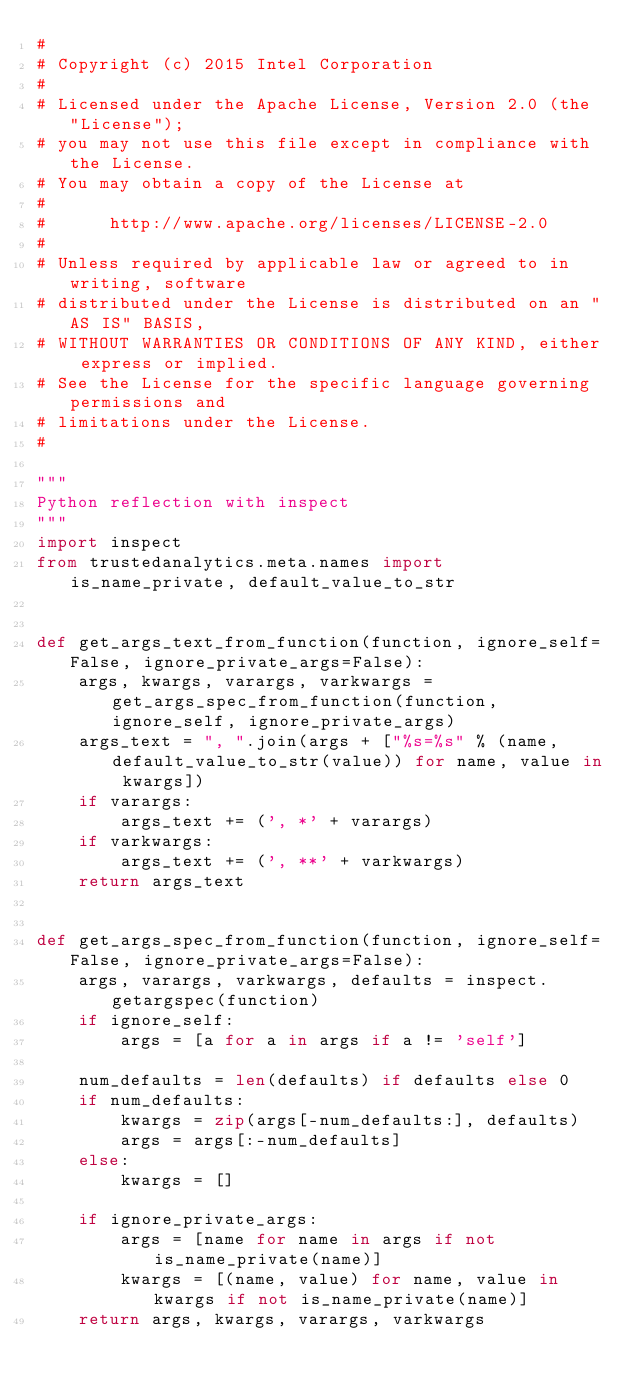Convert code to text. <code><loc_0><loc_0><loc_500><loc_500><_Python_>#
# Copyright (c) 2015 Intel Corporation 
#
# Licensed under the Apache License, Version 2.0 (the "License");
# you may not use this file except in compliance with the License.
# You may obtain a copy of the License at
#
#      http://www.apache.org/licenses/LICENSE-2.0
#
# Unless required by applicable law or agreed to in writing, software
# distributed under the License is distributed on an "AS IS" BASIS,
# WITHOUT WARRANTIES OR CONDITIONS OF ANY KIND, either express or implied.
# See the License for the specific language governing permissions and
# limitations under the License.
#

"""
Python reflection with inspect
"""
import inspect
from trustedanalytics.meta.names import is_name_private, default_value_to_str


def get_args_text_from_function(function, ignore_self=False, ignore_private_args=False):
    args, kwargs, varargs, varkwargs = get_args_spec_from_function(function, ignore_self, ignore_private_args)
    args_text = ", ".join(args + ["%s=%s" % (name, default_value_to_str(value)) for name, value in kwargs])
    if varargs:
        args_text += (', *' + varargs)
    if varkwargs:
        args_text += (', **' + varkwargs)
    return args_text


def get_args_spec_from_function(function, ignore_self=False, ignore_private_args=False):
    args, varargs, varkwargs, defaults = inspect.getargspec(function)
    if ignore_self:
        args = [a for a in args if a != 'self']

    num_defaults = len(defaults) if defaults else 0
    if num_defaults:
        kwargs = zip(args[-num_defaults:], defaults)
        args = args[:-num_defaults]
    else:
        kwargs = []

    if ignore_private_args:
        args = [name for name in args if not is_name_private(name)]
        kwargs = [(name, value) for name, value in kwargs if not is_name_private(name)]
    return args, kwargs, varargs, varkwargs
</code> 